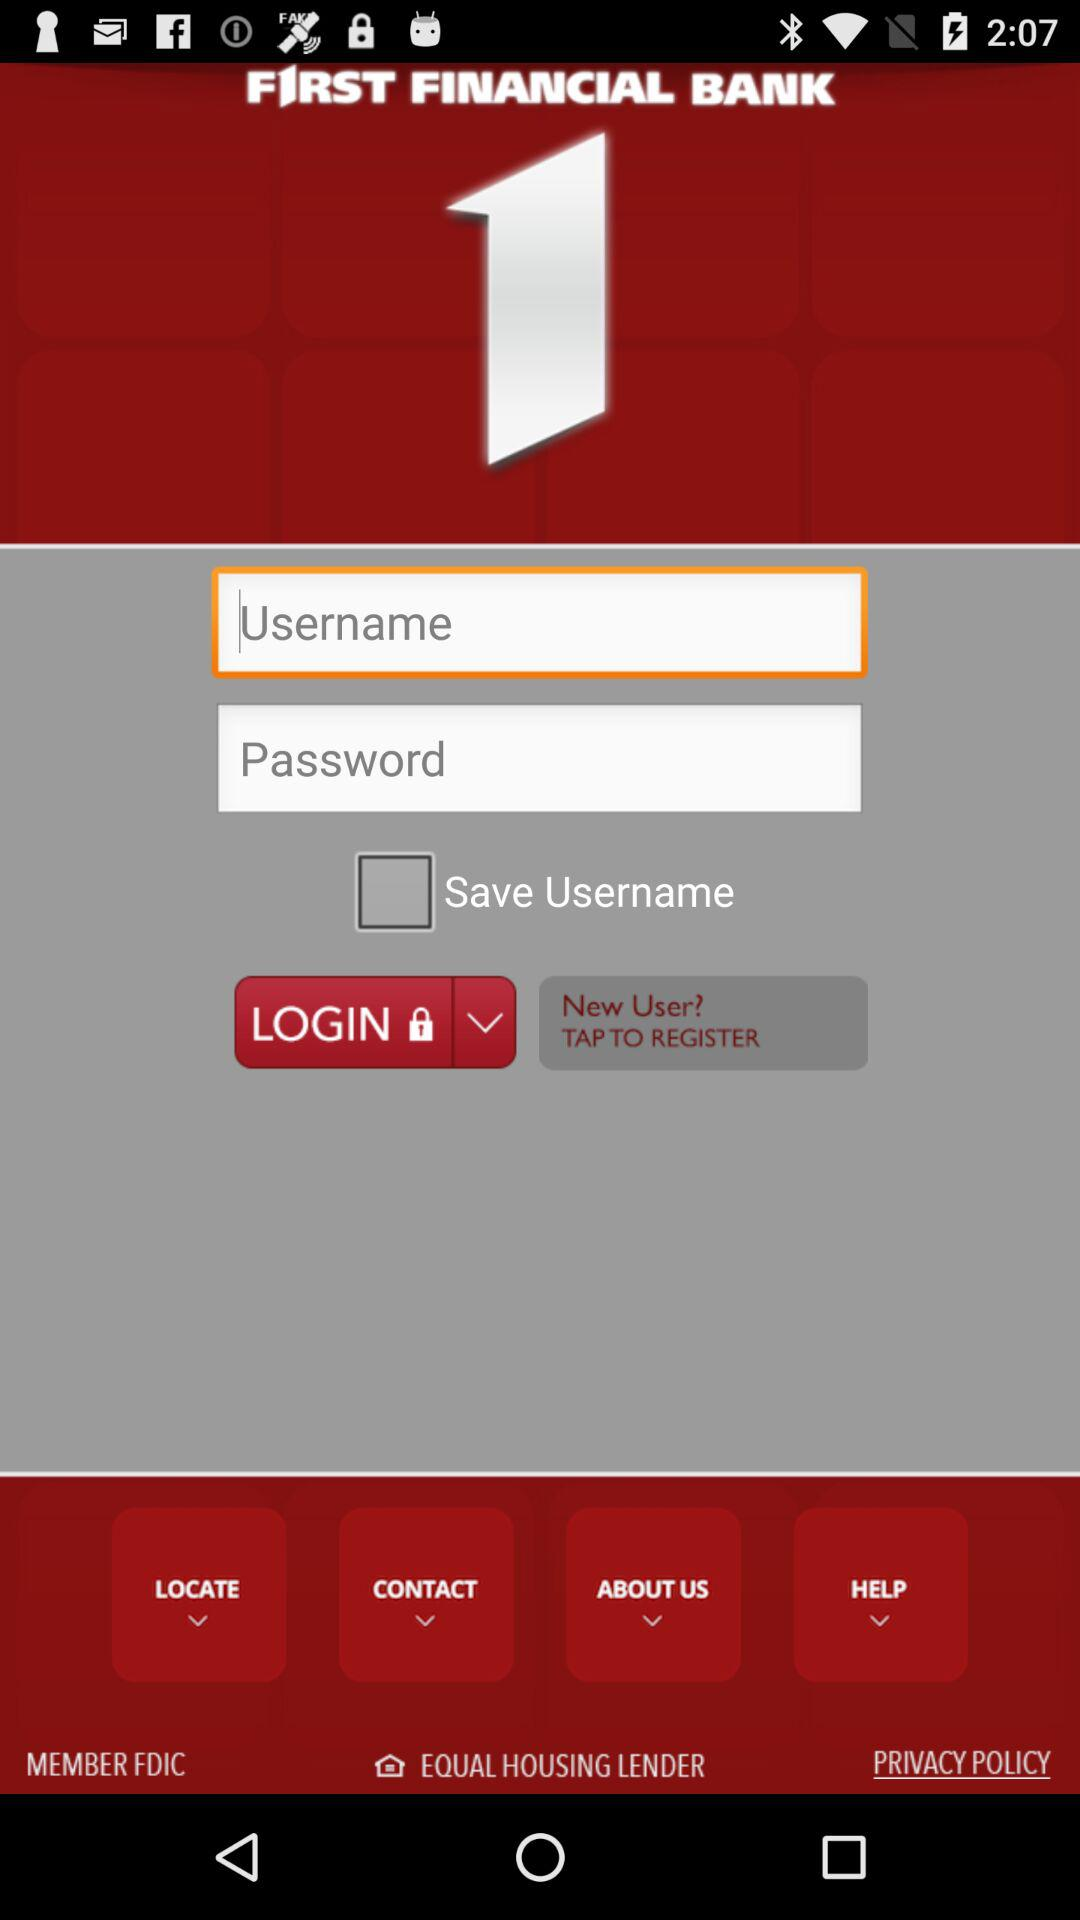What is the name of the application? The name of the application is "FIRST FINANCIAL BANK". 